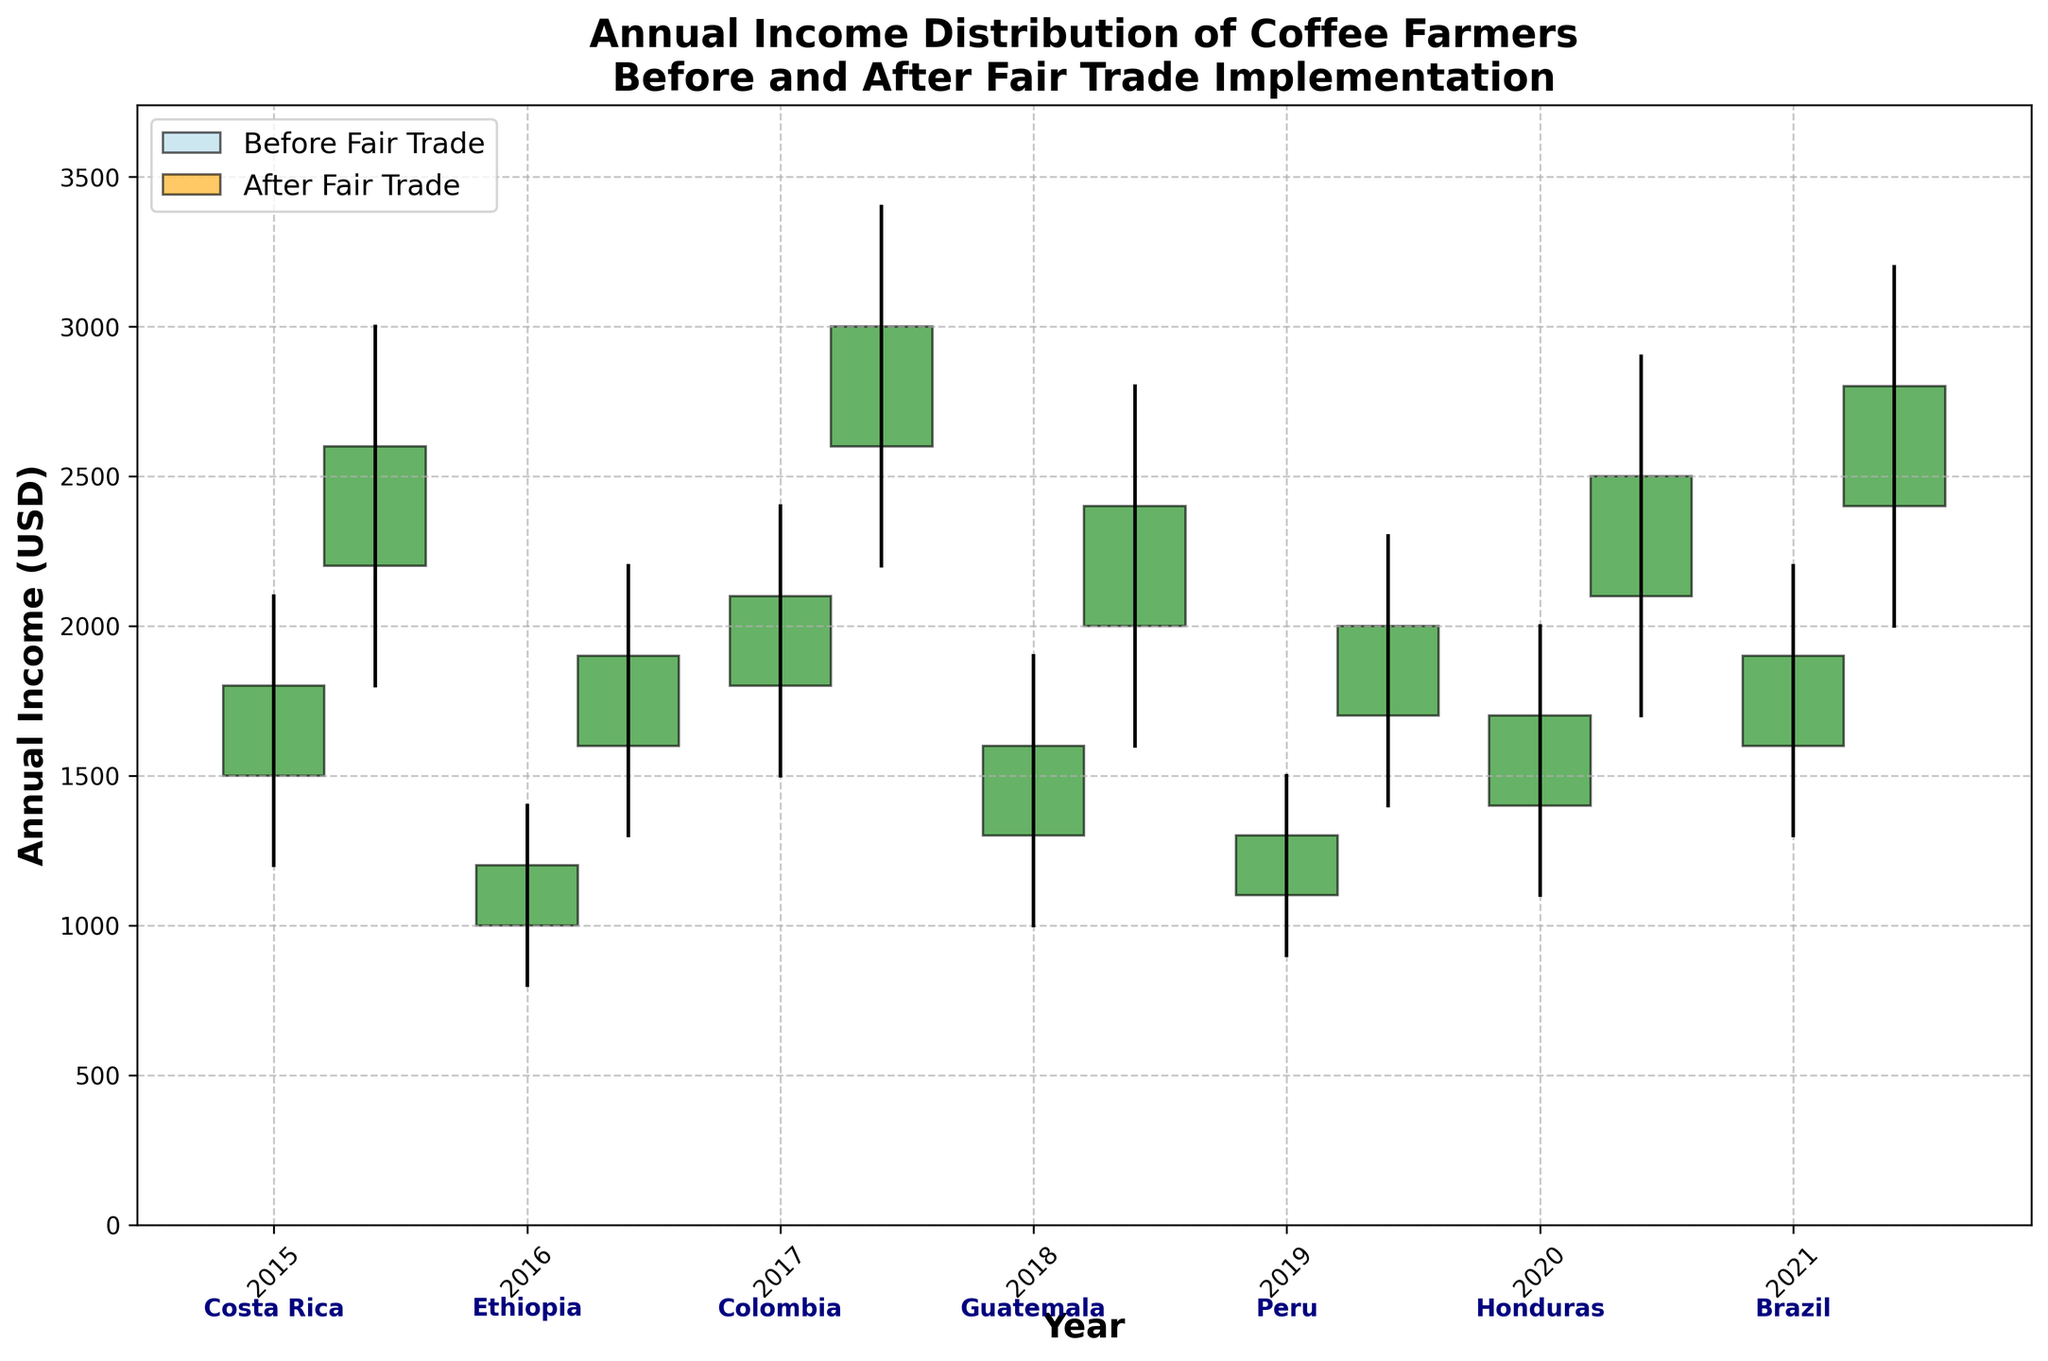What's the title of the figure? The title of the figure is usually found at the top of the plot. It provides a succinct summary of what the figure represents. In this case, it's describing the income distribution of coffee farmers before and after fair trade implementation.
Answer: Annual Income Distribution of Coffee Farmers Before and After Fair Trade Implementation What are the labels of the x and y axes? The x-axis label is found along the horizontal axis and typically describes what the axis represents, while the y-axis label, found along the vertical axis, describes what that axis represents. Here, the x-axis represents the years, and the y-axis represents the annual income in USD.
Answer: Year (x-axis), Annual Income (USD) (y-axis) In 2018, what was the range of annual income for coffee farmers before and after fair trade implementation? The range of annual income is the difference between the high and low values. For 2018, the range before fair trade was from $1000 to $1900, and after fair trade, it was from $1600 to $2800. This information is found by looking at the highest and lowest points of each year's OHLC bar.
Answer: $900 before, $1200 after Which region saw the highest income after the implementation of fair trade in 2021? To determine this, compare the high values from the OHLC bars for 'After Fair Trade' across all years. The highest value can be found in the year 2021. The figure indicates that Brazil saw the highest income in 2021, with a high value of $3200.
Answer: Brazil Did any region experience a decrease in income after fair trade implementation? To identify this, we need to compare the 'Close' (end value) before and after fair trade for each year. If 'After Close' is less than 'Before Close' for any year, the income decreased. By comparing the values across all years, it is evident that no region experienced a decrease, as 'After Close' values are always higher.
Answer: No For which year and region was the increase in income after fair trade the greatest? Calculate the difference between 'After Close' and 'Before Close' for each year and region. The greatest increase occurs where the difference is maximal. The increases are as follows:
- 2015 (Costa Rica): $3000 - $1800 = $1200
- 2016 (Ethiopia): $1900 - $1200 = $700
- 2017 (Colombia): $3000 - $2100 = $900
- 2018 (Guatemala): $2400 - $1600 = $800
- 2019 (Peru): $2000 - $1300 = $700
- 2020 (Honduras): $2500 - $1700 = $800
- 2021 (Brazil): $2800 - $1900 = $900
The greatest increase is in Costa Rica in 2015.
Answer: 2015, Costa Rica What's the trend of annual income for coffee farmers from 2015 to 2021, both before and after fair trade? Observing the bars from left to right, there is a noticeable upward trend in the 'Close' values (indicative of the end yearly income) for both before and after fair trade across the years. The consistent increase suggests that incomes have generally risen year-over-year from 2015 to 2021.
Answer: Upward trend How does the variability in income (range between high and low) before and after fair trade compare in 2020? Compare the difference between high and low values for 2020:
- Before: High $2000, Low $1100 → Range = $900
- After: High $2900, Low $1700 → Range = $1200
The range increased after fair trade was implemented, indicating greater variability.
Answer: Higher after fair trade Which year showed the smallest difference between 'Before Close' and 'After Close' income? Calculate the difference between 'Before Close' and 'After Close' for each year:
- 2015: $1200 
- 2016: $700
- 2017: $900
- 2018: $800
- 2019: $700
- 2020: $800
- 2021: $900
The smallest difference occurs in 2016 and 2019 (tie).
Answer: 2016 and 2019 Which region had the highest 'Before High' value and what was it? Compare the 'Before High' values across all years to identify the largest value. For 2017 (Colombia), the highest value is $2400, which is the highest 'Before High' value in the dataset.
Answer: Colombia, $2400 